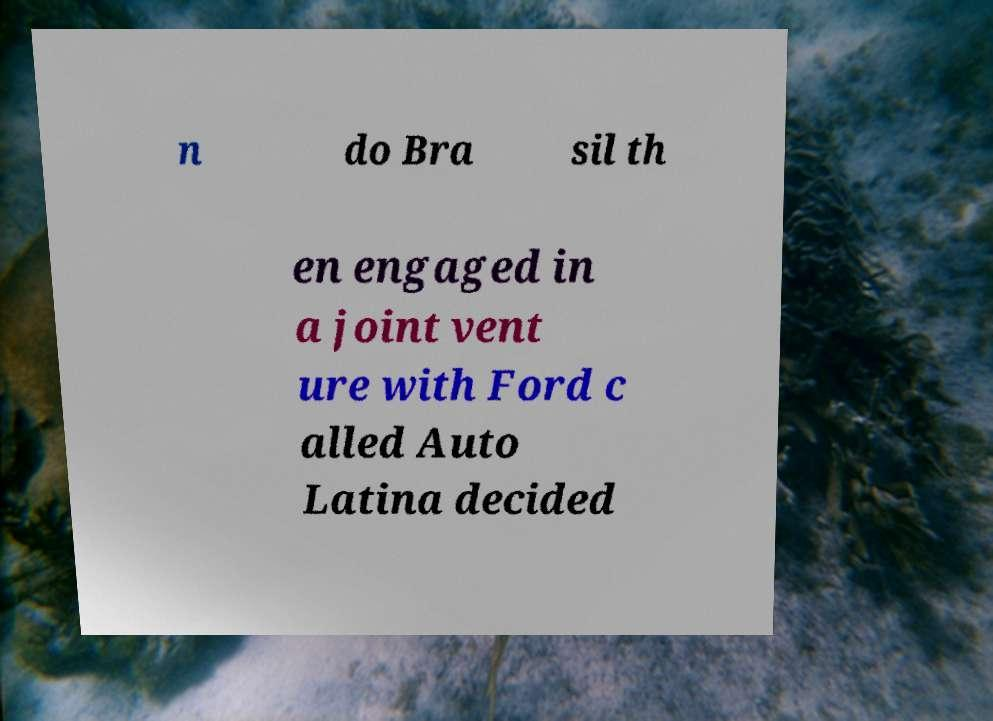Can you accurately transcribe the text from the provided image for me? n do Bra sil th en engaged in a joint vent ure with Ford c alled Auto Latina decided 